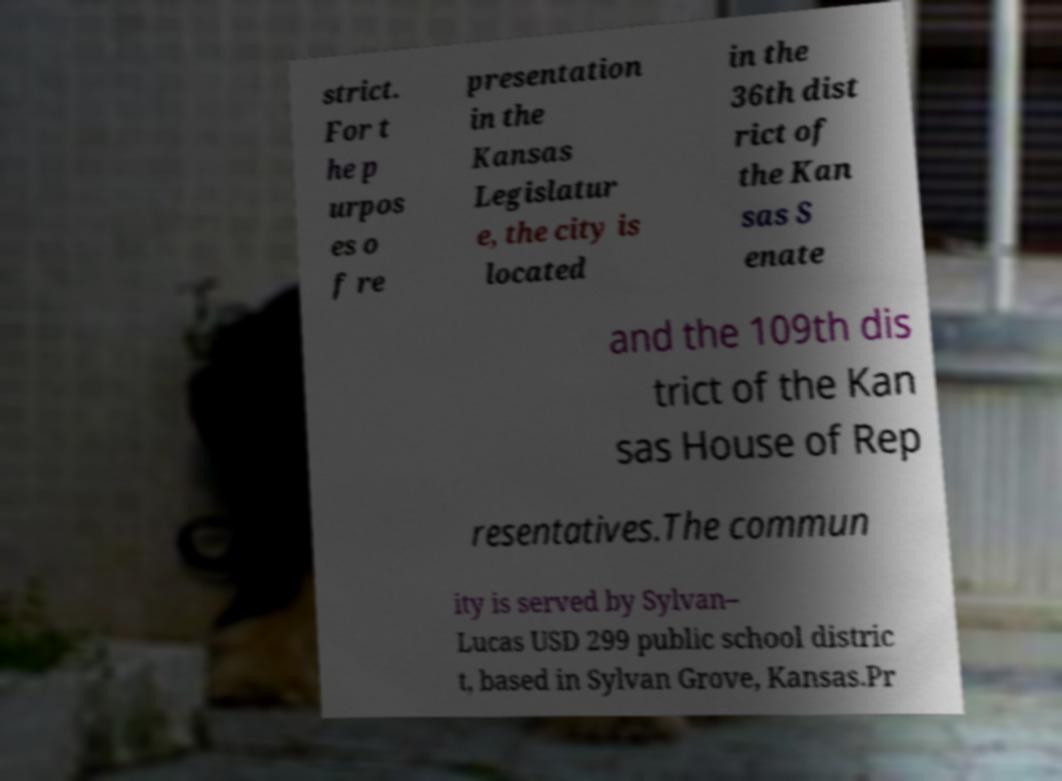Could you extract and type out the text from this image? strict. For t he p urpos es o f re presentation in the Kansas Legislatur e, the city is located in the 36th dist rict of the Kan sas S enate and the 109th dis trict of the Kan sas House of Rep resentatives.The commun ity is served by Sylvan– Lucas USD 299 public school distric t, based in Sylvan Grove, Kansas.Pr 